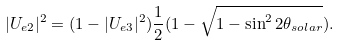Convert formula to latex. <formula><loc_0><loc_0><loc_500><loc_500>| U _ { e 2 } | ^ { 2 } = ( 1 - | U _ { e 3 } | ^ { 2 } ) \frac { 1 } { 2 } ( 1 - \sqrt { 1 - \sin ^ { 2 } { 2 \theta _ { s o l a r } } } ) .</formula> 